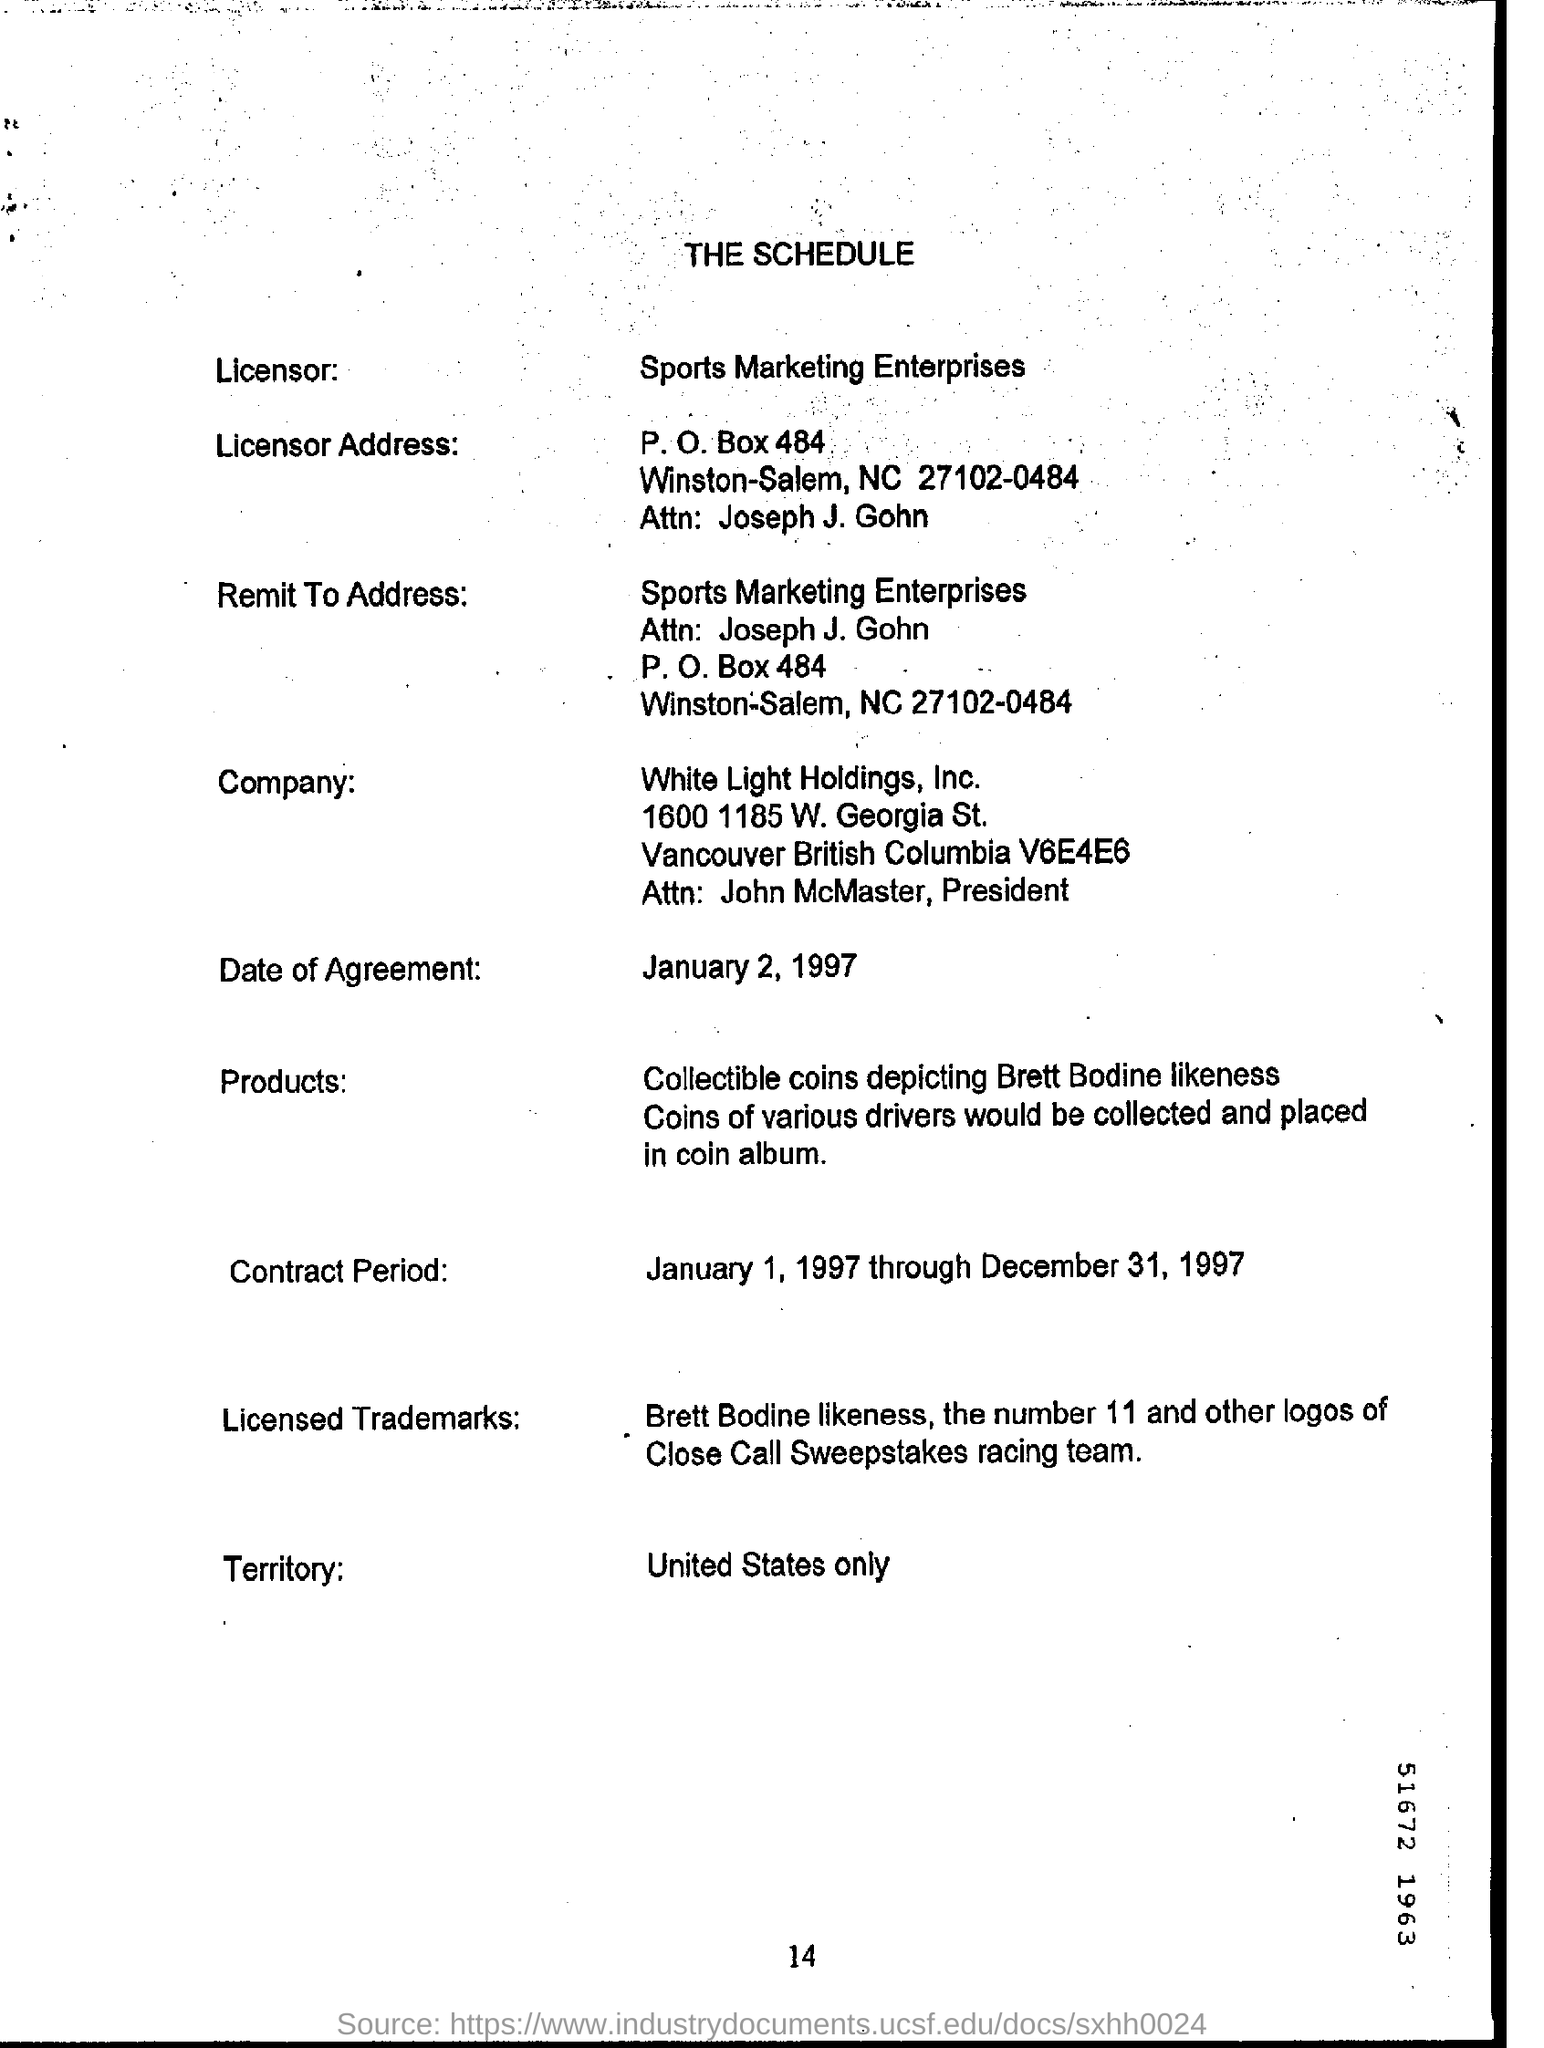What is the Title of the document ?
Give a very brief answer. THE SCHEDULE. Who is the Licensor ?
Give a very brief answer. Sports Marketing Enterprises. What is the Company Name ?
Your answer should be very brief. White Light Holdings. What is the Date of Agreement ?
Offer a terse response. January 2, 1997. What is the Licesor P.O Box Number ?
Provide a short and direct response. 484. 